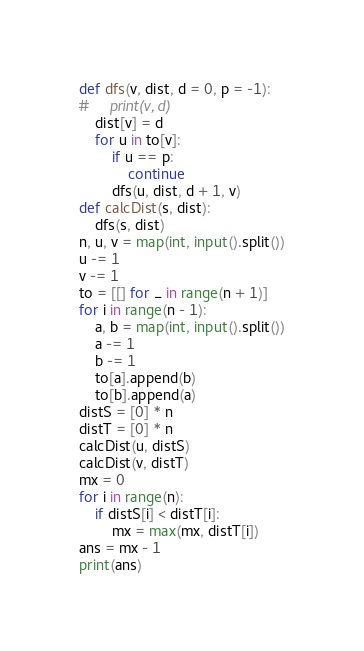<code> <loc_0><loc_0><loc_500><loc_500><_Python_>def dfs(v, dist, d = 0, p = -1):
#     print(v, d)
    dist[v] = d
    for u in to[v]:
        if u == p:
            continue
        dfs(u, dist, d + 1, v)
def calcDist(s, dist):
    dfs(s, dist)        
n, u, v = map(int, input().split())
u -= 1
v -= 1
to = [[] for _ in range(n + 1)]
for i in range(n - 1):
    a, b = map(int, input().split())
    a -= 1
    b -= 1
    to[a].append(b)
    to[b].append(a)
distS = [0] * n
distT = [0] * n
calcDist(u, distS)
calcDist(v, distT)
mx = 0
for i in range(n):
    if distS[i] < distT[i]:
        mx = max(mx, distT[i])
ans = mx - 1
print(ans)</code> 